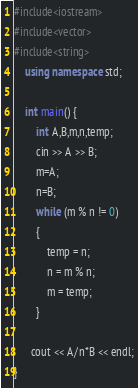<code> <loc_0><loc_0><loc_500><loc_500><_C++_>#include<iostream>
#include<vector>
#include<string>
    using namespace std;
     
    int main() {
    	int A,B,m,n,temp;
    	cin >> A >> B;
        m=A;
        n=B;
		while (m % n != 0)
		{
			temp = n;
			n = m % n;
			m = temp;
		}
      
      cout << A/n*B << endl;
}</code> 